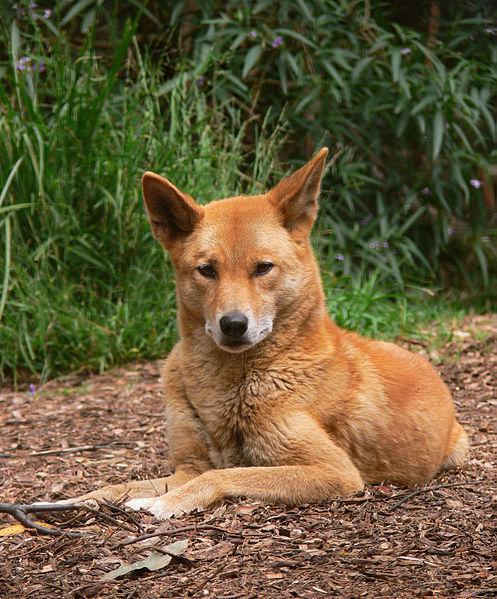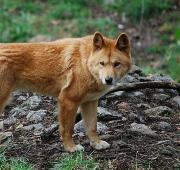The first image is the image on the left, the second image is the image on the right. Evaluate the accuracy of this statement regarding the images: "The canine on the left is laying down, the canine on the right is standing up.". Is it true? Answer yes or no. Yes. The first image is the image on the left, the second image is the image on the right. Examine the images to the left and right. Is the description "One of the images shows exactly one animal in the grass alone." accurate? Answer yes or no. No. 